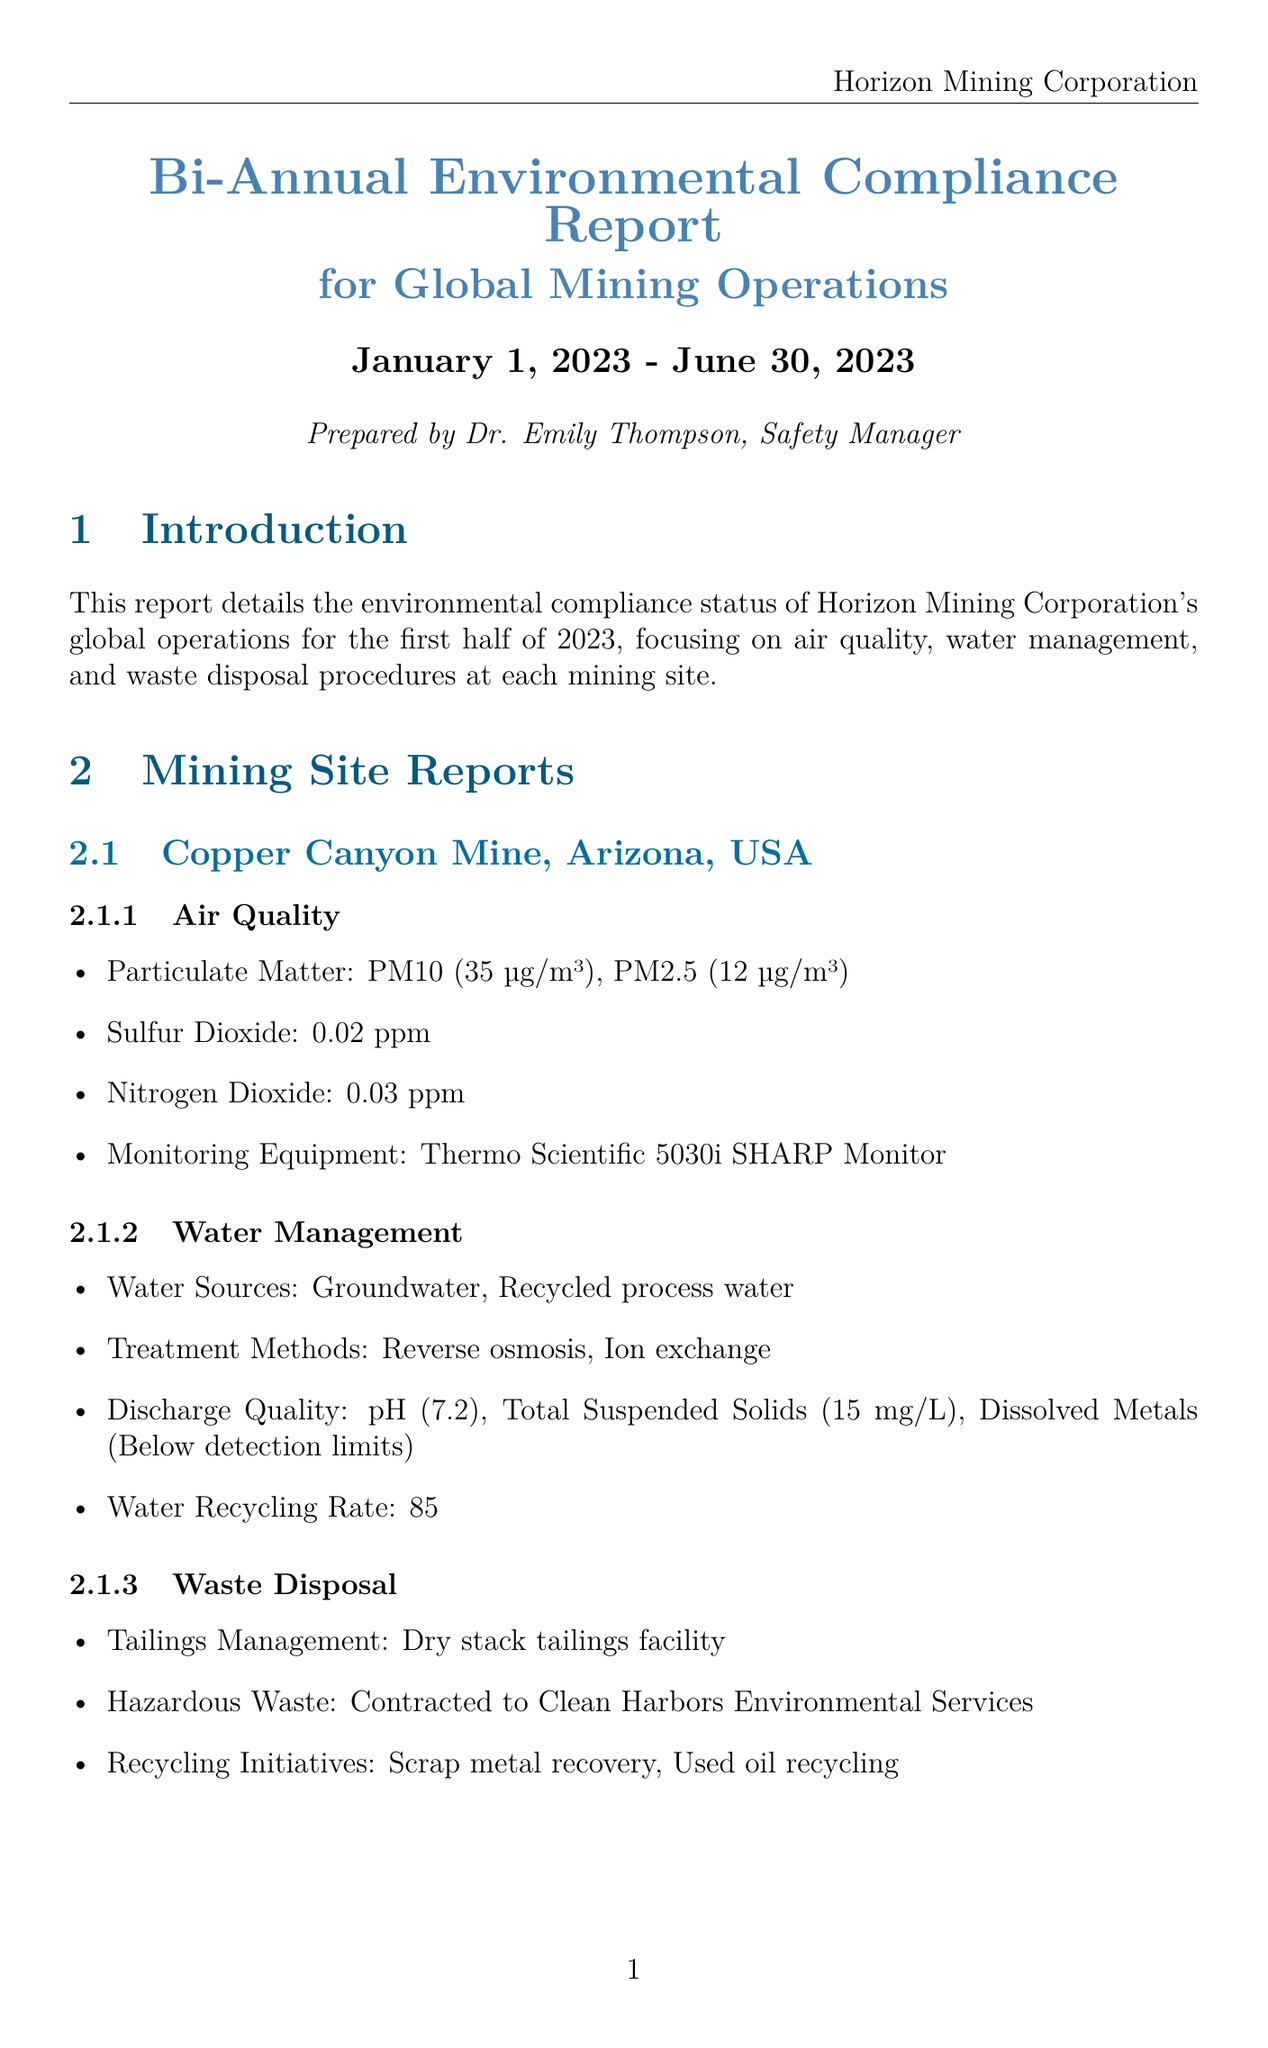what is the report title? The report title is stated at the beginning of the document, which is "Bi-Annual Environmental Compliance Report for Global Mining Operations."
Answer: Bi-Annual Environmental Compliance Report for Global Mining Operations what is the air quality compliance status? The compliance summary section mentions that "All sites meeting National Ambient Air Quality Standards."
Answer: All sites meeting National Ambient Air Quality Standards what is the water recycling rate at Copper Canyon Mine? The document specifies water management practices at Copper Canyon Mine, stating a recycling rate of "85%."
Answer: 85% which company manages hazardous waste at Blackstone Coal Mine? The waste disposal section for Blackstone Coal Mine indicates that hazardous waste is managed by "Veolia Environmental Services."
Answer: Veolia Environmental Services how many mining sites are reported? The document lists two mining sites under the mining sites section, indicating the total number of sites.
Answer: 2 what is one of the future goals mentioned? The future goals section outlines various objectives, one of which is to "reduce overall water consumption by 15% in the next reporting period."
Answer: Reduce overall water consumption by 15% in the next reporting period which equipment is used for air quality monitoring at Copper Canyon Mine? The air quality section for Copper Canyon Mine specifies that the monitoring equipment used is "Thermo Scientific 5030i SHARP Monitor."
Answer: Thermo Scientific 5030i SHARP Monitor what treatment methods are used for water management at Blackstone Coal Mine? The water management section describes treatment methods adopted, which are "Sedimentation, Filtration."
Answer: Sedimentation, Filtration 